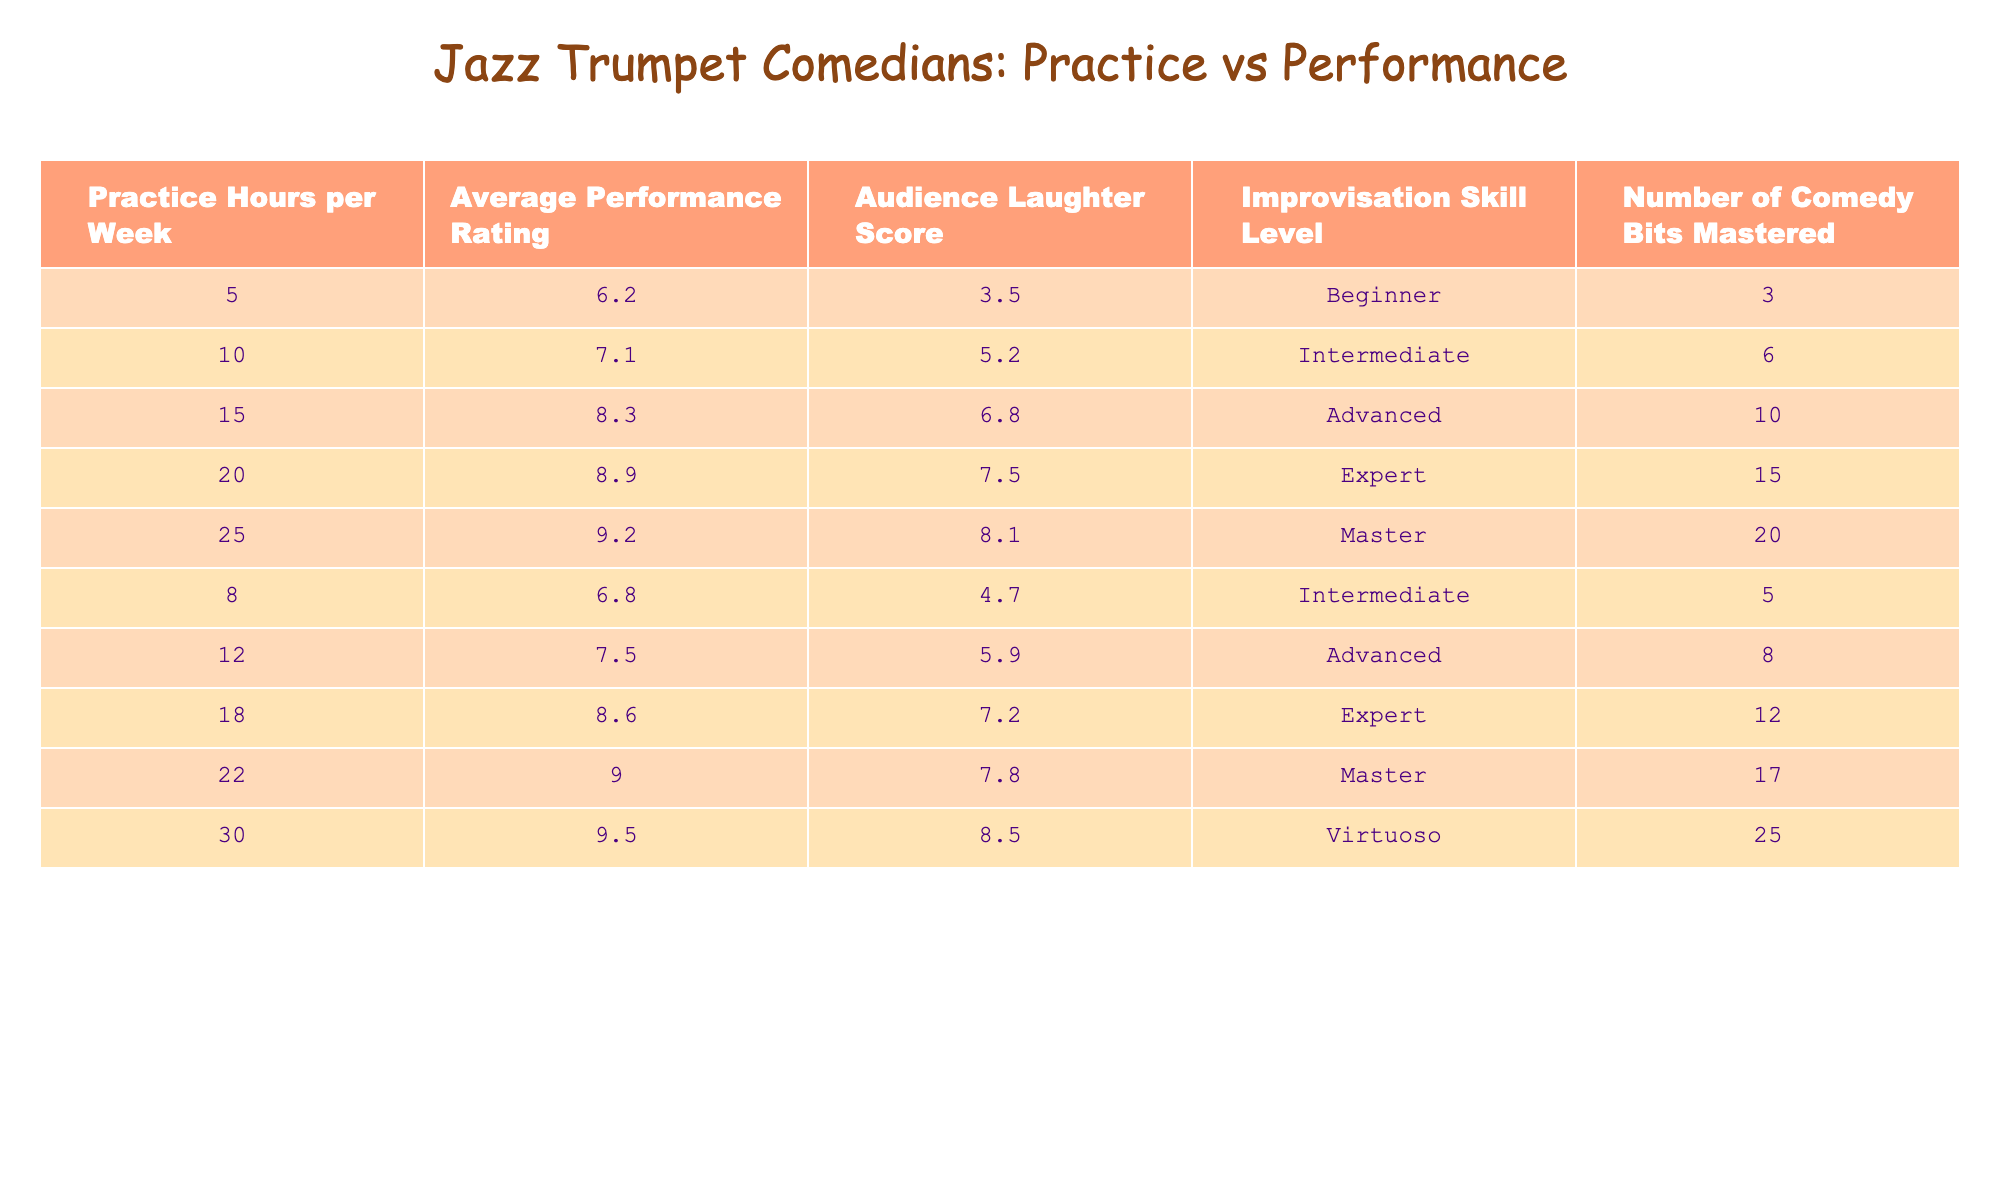What is the highest average performance rating among the practice hours? The table indicates that the average performance rating is highest at 9.5 for 30 practice hours per week.
Answer: 9.5 What is the relationship between practice hours and audience laughter score? The data shows that as practice hours increase, the audience laughter score also tends to increase, indicating a positive correlation.
Answer: Positive correlation How many comedy bits are mastered by the individual practicing 12 hours per week? According to the table, the individual who practices for 12 hours has mastered 8 comedy bits.
Answer: 8 What is the average improvisation skill level for those practicing more than 15 hours per week? Reviewing the data, the improvisation skills for practice hours 20, 25, and 30 are Expert, Master, and Virtuoso, respectively. Averaging gives us (3 + 4 + 5)/3 = 4 (where Beginner = 1, Intermediate = 2, Advanced = 3, Expert = 4, Master = 5, Virtuoso = 6).
Answer: 4 Is there a performer who scores an audience laughter score of 5.9 with 12 practice hours? There is an entry with 12 practice hours that scores an audience laughter score of 5.9, confirming this statement to be true.
Answer: True What is the total number of comedy bits mastered by performers practicing for 5, 10, and 15 hours per week? The comedy bits mastered by those practicing 5, 10, and 15 hours are 3, 6, and 10, respectively. Summing these gives 3 + 6 + 10 = 19 total comedy bits.
Answer: 19 What percentage of performers practicing 20 or more hours achieved an average performance rating above 9? The performers at 20, 25, and 30 hours scored 8.9, 9.2, and 9.5, all above 9. Therefore, 3 out of 5 individuals (60%) reached that level.
Answer: 60% How does the average audience laughter score for practitioners with 15 hours compare to those with 5 hours? The average audience laughter score for 15 hours is 6.8, while for 5 hours it is 3.5. The difference is 6.8 - 3.5 = 3.3, showing that those with 15 hours score significantly higher.
Answer: 3.3 What is the overall trend in average performance rating relative to the increase in practice hours? The average performance rating increases consistently as practice hours rise from 5 to 30, illustrating a clear upward trend in performance quality.
Answer: Upward trend 